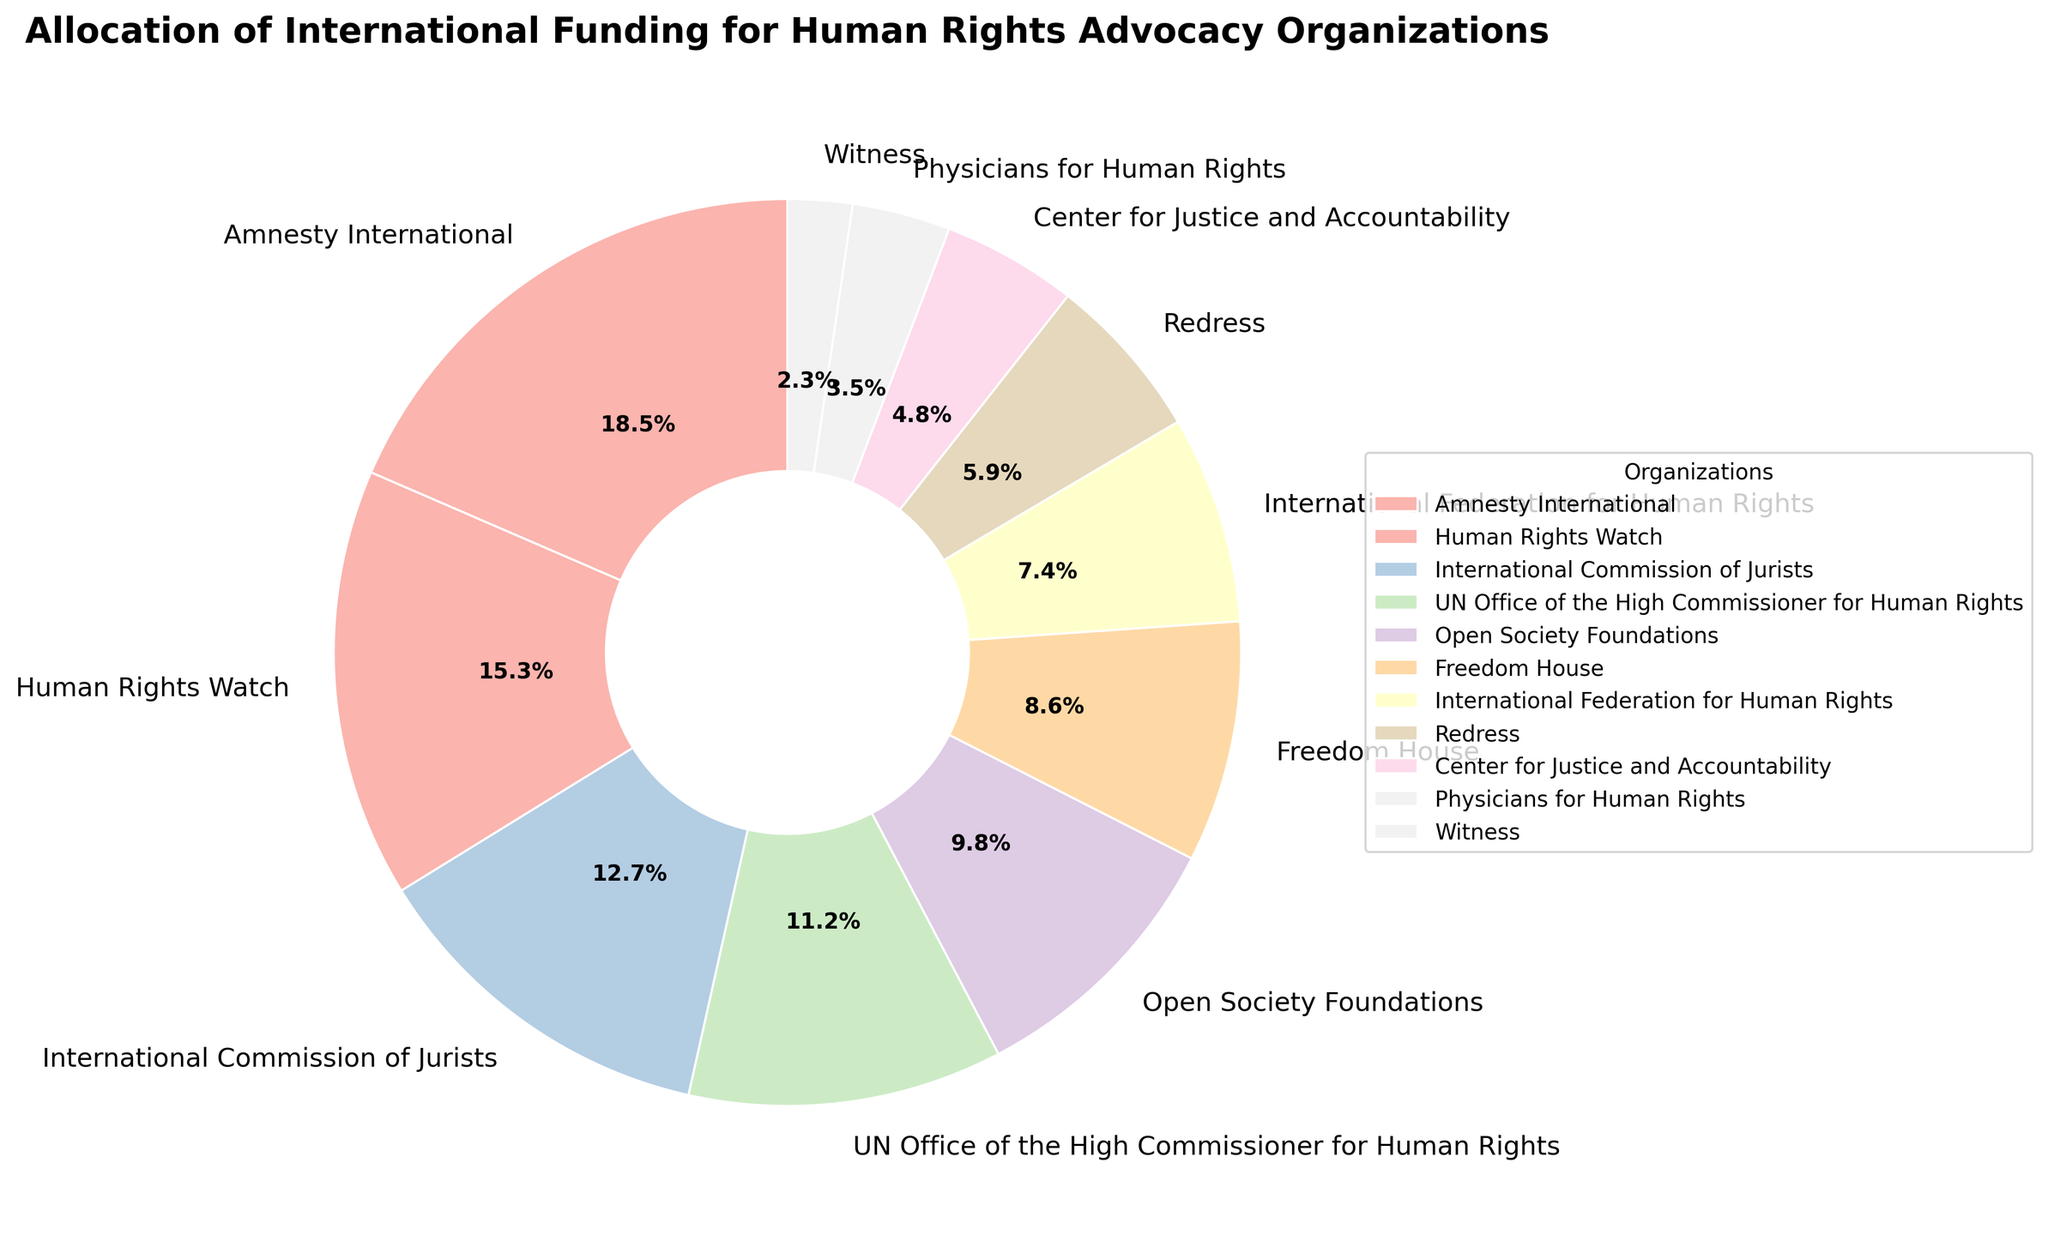Which organization receives the largest allocation of international funding? To determine the organization with the largest allocation, look at the highest percentage value in the pie chart's labels. Amnesty International has the highest percentage with 18.5%.
Answer: Amnesty International What is the combined funding allocation of Freedom House and Redress? Add the percentages allocated to Freedom House (8.6%) and Redress (5.9%). The combined funding allocation is 8.6% + 5.9% = 14.5%.
Answer: 14.5% Which organizations have a funding allocation greater than 10%? Check the labels for percentages above 10%. Amnesty International (18.5%), Human Rights Watch (15.3%), International Commission of Jurists (12.7%), and UN Office of the High Commissioner for Human Rights (11.2%) meet this criterion.
Answer: Amnesty International, Human Rights Watch, International Commission of Jurists, UN Office of the High Commissioner for Human Rights How much more funding does Human Rights Watch receive compared to Physicians for Human Rights? Subtract the percentage allocation of Physicians for Human Rights (3.5%) from Human Rights Watch (15.3%). The difference is 15.3% - 3.5% = 11.8%.
Answer: 11.8% What is the average funding allocation of the organizations listed? Sum all the percentage allocations and divide by the number of organizations: (18.5 + 15.3 + 12.7 + 11.2 + 9.8 + 8.6 + 7.4 + 5.9 + 4.8 + 3.5 + 2.3) / 11 = 100 / 11 ≈ 9.09%.
Answer: 9.09% Which organization receives the least funding allocation, and what is its percentage? Find the smallest percentage value in the chart. Witness has the least funding allocation at 2.3%.
Answer: Witness, 2.3% What is the difference in funding allocation between the highest and the lowest funded organizations? Subtract the percentage of the least funded organization (Witness at 2.3%) from the highest funded organization (Amnesty International at 18.5%). The difference is 18.5% - 2.3% = 16.2%.
Answer: 16.2% How does the funding allocation of the International Federation for Human Rights compare to Open Society Foundations? Compare the percentages: International Federation for Human Rights has 7.4% and Open Society Foundations has 9.8%. The funding allocation for the International Federation for Human Rights is 2.4% less.
Answer: 2.4% less 